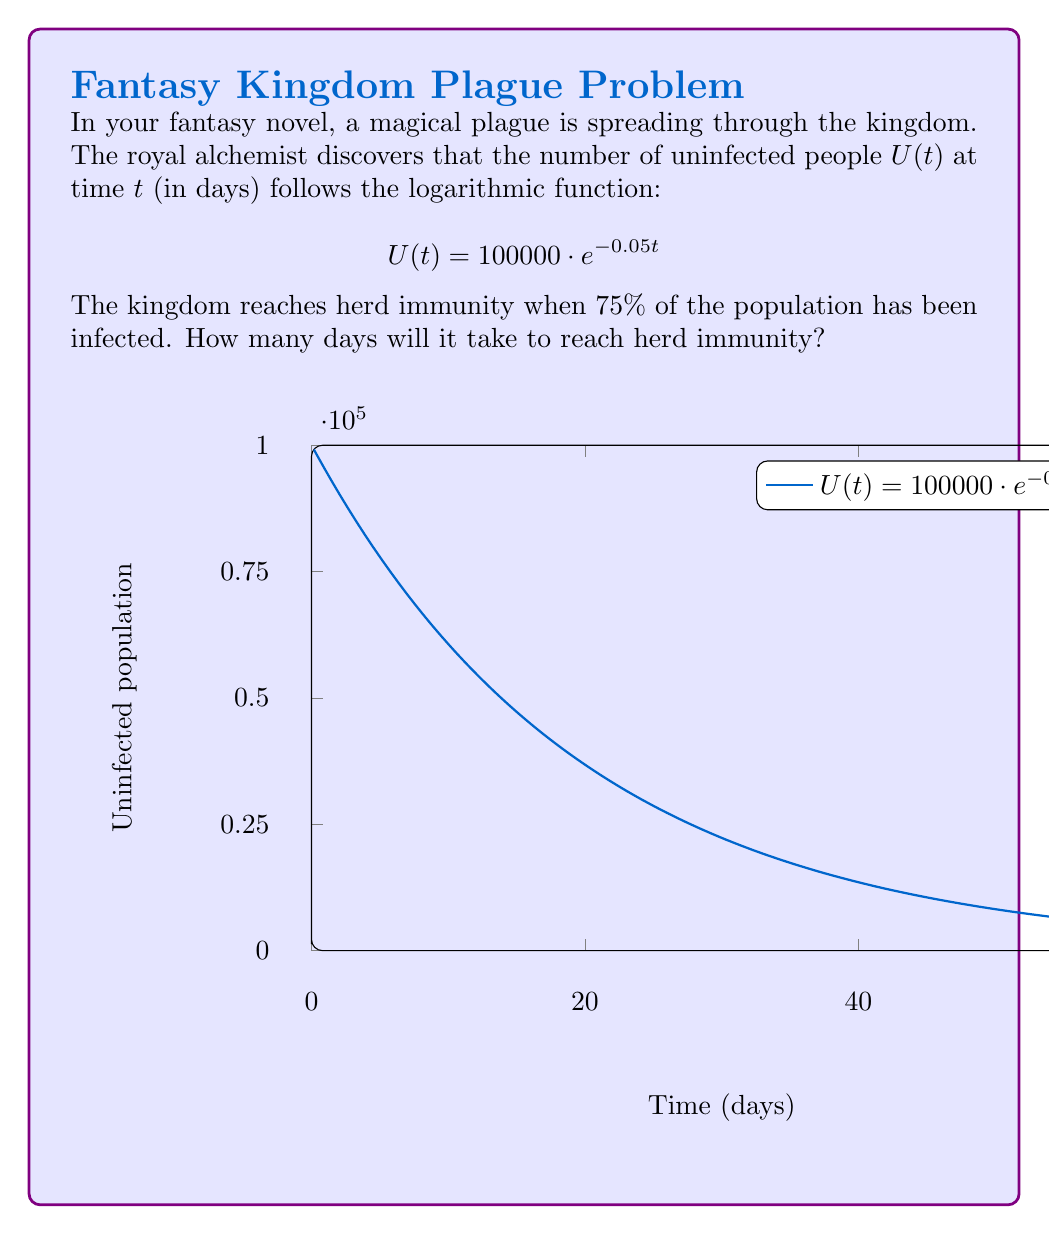Solve this math problem. Let's approach this step-by-step:

1) The initial population is 100,000 people.

2) Herd immunity is reached when 75% of the population is infected, meaning 25% remains uninfected.

3) We need to find $t$ when $U(t) = 25000$ (25% of 100,000).

4) We can set up the equation:

   $$25000 = 100000 \cdot e^{-0.05t}$$

5) Divide both sides by 100,000:

   $$0.25 = e^{-0.05t}$$

6) Take the natural log of both sides:

   $$\ln(0.25) = -0.05t$$

7) Solve for $t$:

   $$t = \frac{\ln(0.25)}{-0.05}$$

8) Calculate:

   $$t = \frac{-1.3862943611198906}{-0.05} \approx 27.73$$

9) Since we can't have a fractional day, we round up to the nearest whole day.
Answer: 28 days 